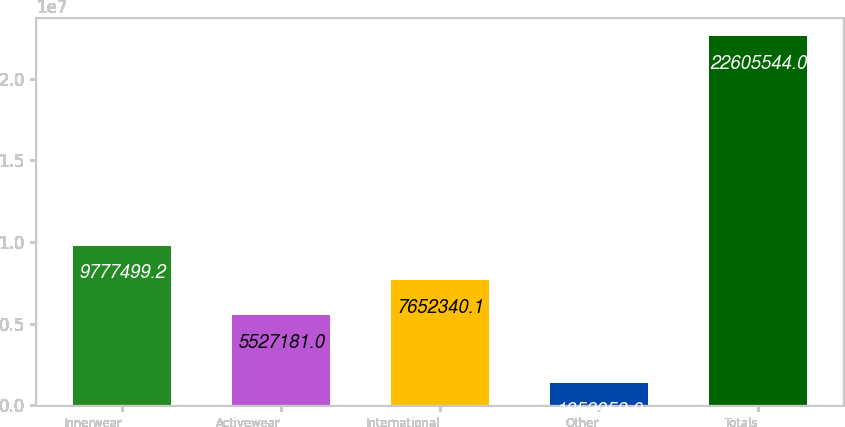Convert chart to OTSL. <chart><loc_0><loc_0><loc_500><loc_500><bar_chart><fcel>Innerwear<fcel>Activewear<fcel>International<fcel>Other<fcel>Totals<nl><fcel>9.7775e+06<fcel>5.52718e+06<fcel>7.65234e+06<fcel>1.35395e+06<fcel>2.26055e+07<nl></chart> 